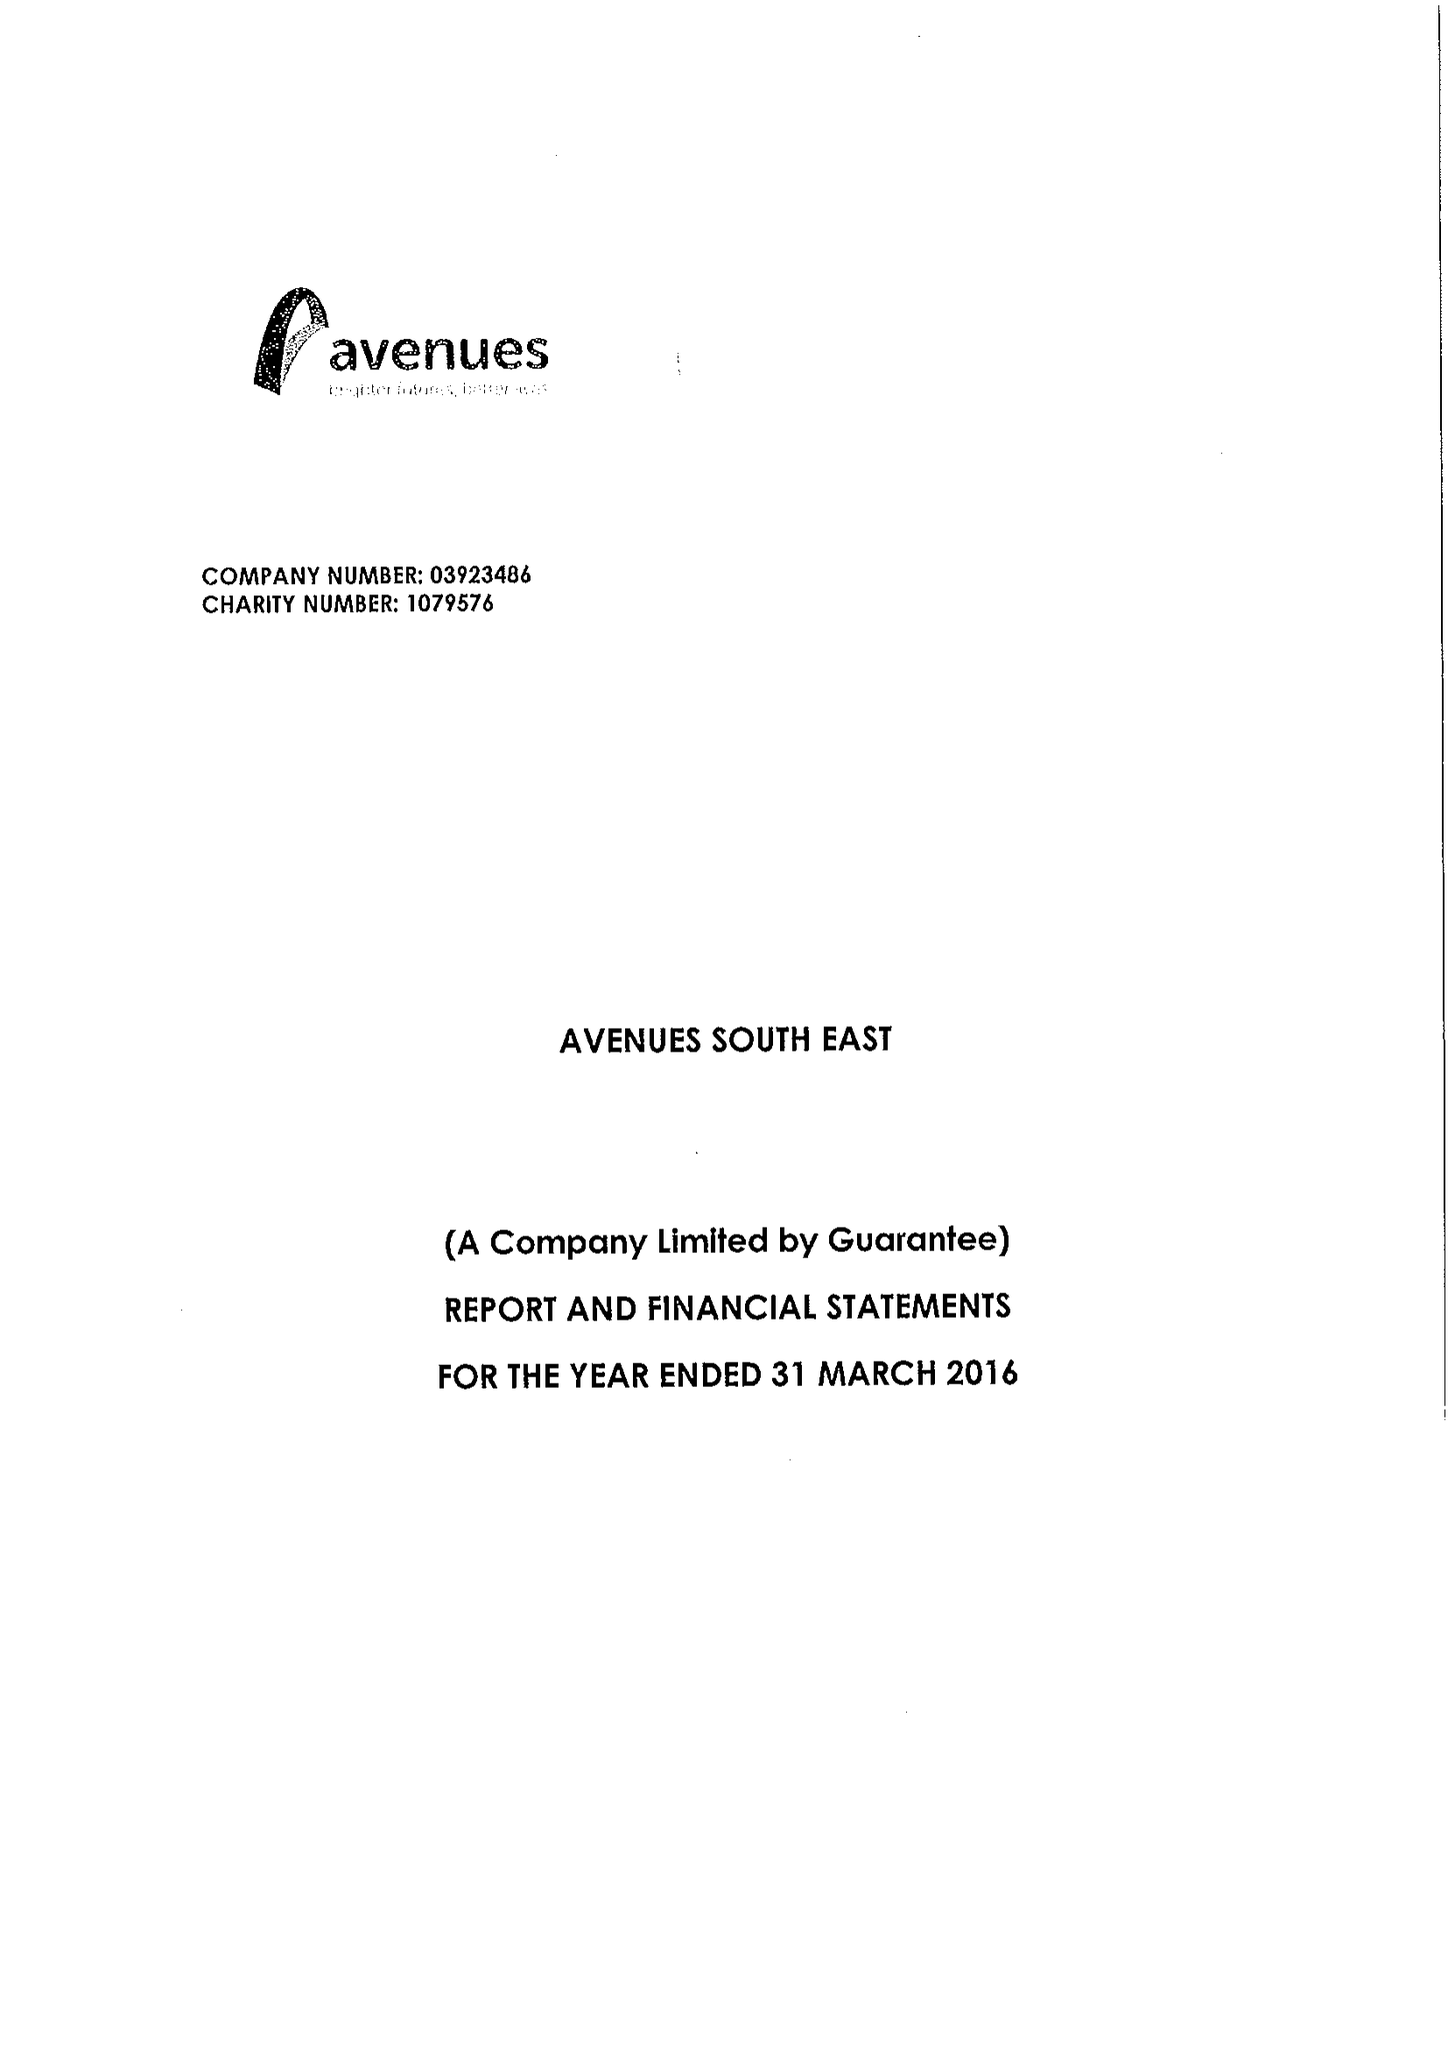What is the value for the spending_annually_in_british_pounds?
Answer the question using a single word or phrase. 13947442.00 